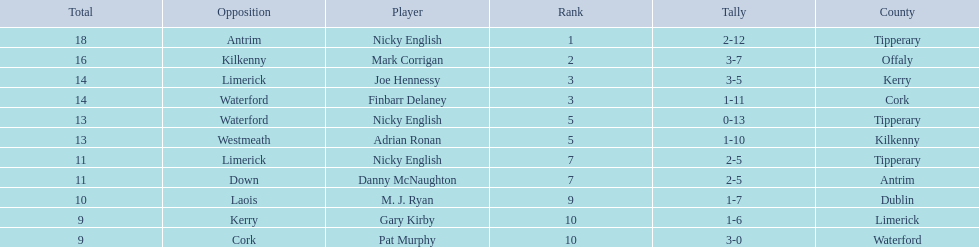What player got 10 total points in their game? M. J. Ryan. 